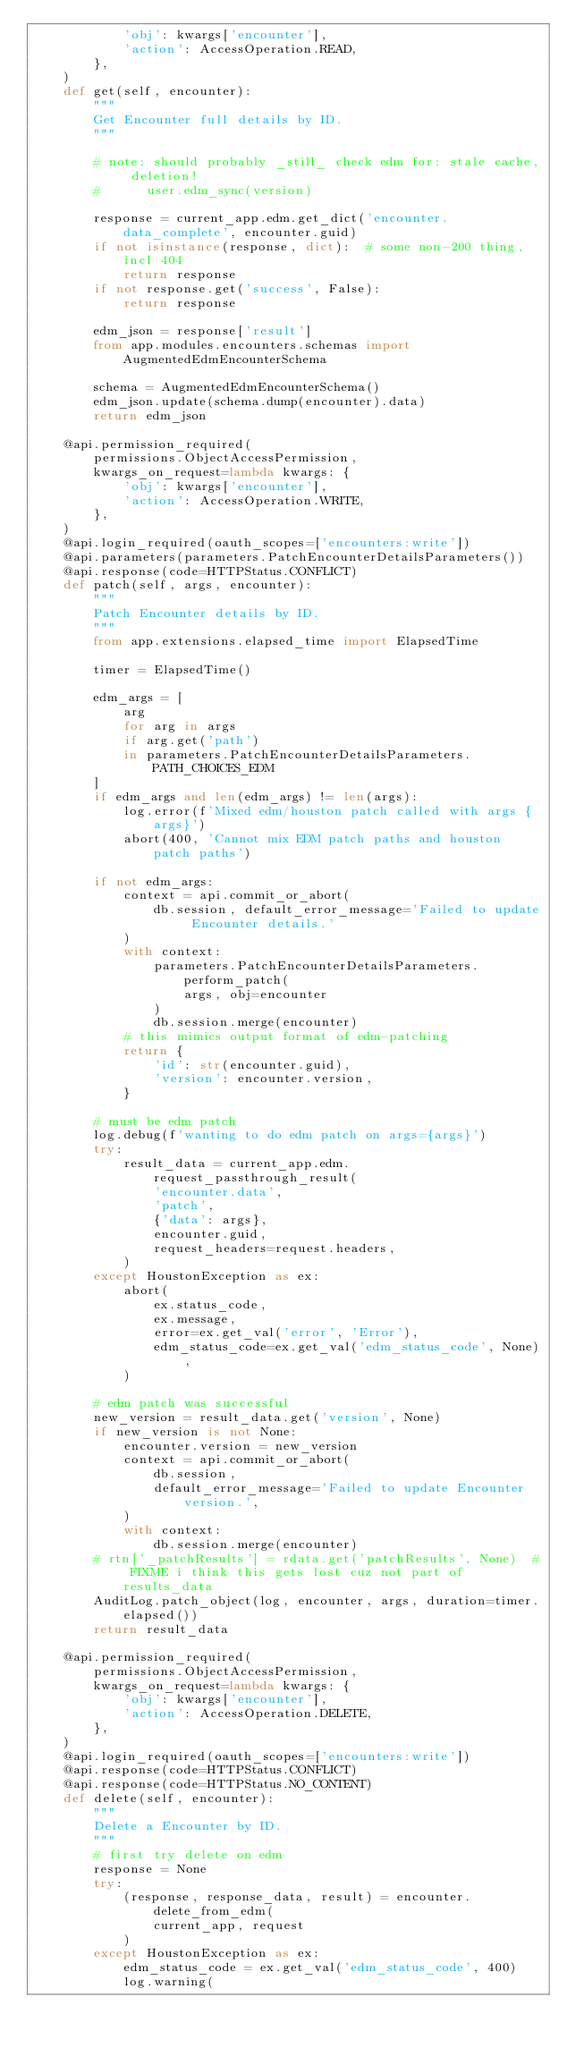<code> <loc_0><loc_0><loc_500><loc_500><_Python_>            'obj': kwargs['encounter'],
            'action': AccessOperation.READ,
        },
    )
    def get(self, encounter):
        """
        Get Encounter full details by ID.
        """

        # note: should probably _still_ check edm for: stale cache, deletion!
        #      user.edm_sync(version)

        response = current_app.edm.get_dict('encounter.data_complete', encounter.guid)
        if not isinstance(response, dict):  # some non-200 thing, incl 404
            return response
        if not response.get('success', False):
            return response

        edm_json = response['result']
        from app.modules.encounters.schemas import AugmentedEdmEncounterSchema

        schema = AugmentedEdmEncounterSchema()
        edm_json.update(schema.dump(encounter).data)
        return edm_json

    @api.permission_required(
        permissions.ObjectAccessPermission,
        kwargs_on_request=lambda kwargs: {
            'obj': kwargs['encounter'],
            'action': AccessOperation.WRITE,
        },
    )
    @api.login_required(oauth_scopes=['encounters:write'])
    @api.parameters(parameters.PatchEncounterDetailsParameters())
    @api.response(code=HTTPStatus.CONFLICT)
    def patch(self, args, encounter):
        """
        Patch Encounter details by ID.
        """
        from app.extensions.elapsed_time import ElapsedTime

        timer = ElapsedTime()

        edm_args = [
            arg
            for arg in args
            if arg.get('path')
            in parameters.PatchEncounterDetailsParameters.PATH_CHOICES_EDM
        ]
        if edm_args and len(edm_args) != len(args):
            log.error(f'Mixed edm/houston patch called with args {args}')
            abort(400, 'Cannot mix EDM patch paths and houston patch paths')

        if not edm_args:
            context = api.commit_or_abort(
                db.session, default_error_message='Failed to update Encounter details.'
            )
            with context:
                parameters.PatchEncounterDetailsParameters.perform_patch(
                    args, obj=encounter
                )
                db.session.merge(encounter)
            # this mimics output format of edm-patching
            return {
                'id': str(encounter.guid),
                'version': encounter.version,
            }

        # must be edm patch
        log.debug(f'wanting to do edm patch on args={args}')
        try:
            result_data = current_app.edm.request_passthrough_result(
                'encounter.data',
                'patch',
                {'data': args},
                encounter.guid,
                request_headers=request.headers,
            )
        except HoustonException as ex:
            abort(
                ex.status_code,
                ex.message,
                error=ex.get_val('error', 'Error'),
                edm_status_code=ex.get_val('edm_status_code', None),
            )

        # edm patch was successful
        new_version = result_data.get('version', None)
        if new_version is not None:
            encounter.version = new_version
            context = api.commit_or_abort(
                db.session,
                default_error_message='Failed to update Encounter version.',
            )
            with context:
                db.session.merge(encounter)
        # rtn['_patchResults'] = rdata.get('patchResults', None)  # FIXME i think this gets lost cuz not part of results_data
        AuditLog.patch_object(log, encounter, args, duration=timer.elapsed())
        return result_data

    @api.permission_required(
        permissions.ObjectAccessPermission,
        kwargs_on_request=lambda kwargs: {
            'obj': kwargs['encounter'],
            'action': AccessOperation.DELETE,
        },
    )
    @api.login_required(oauth_scopes=['encounters:write'])
    @api.response(code=HTTPStatus.CONFLICT)
    @api.response(code=HTTPStatus.NO_CONTENT)
    def delete(self, encounter):
        """
        Delete a Encounter by ID.
        """
        # first try delete on edm
        response = None
        try:
            (response, response_data, result) = encounter.delete_from_edm(
                current_app, request
            )
        except HoustonException as ex:
            edm_status_code = ex.get_val('edm_status_code', 400)
            log.warning(</code> 